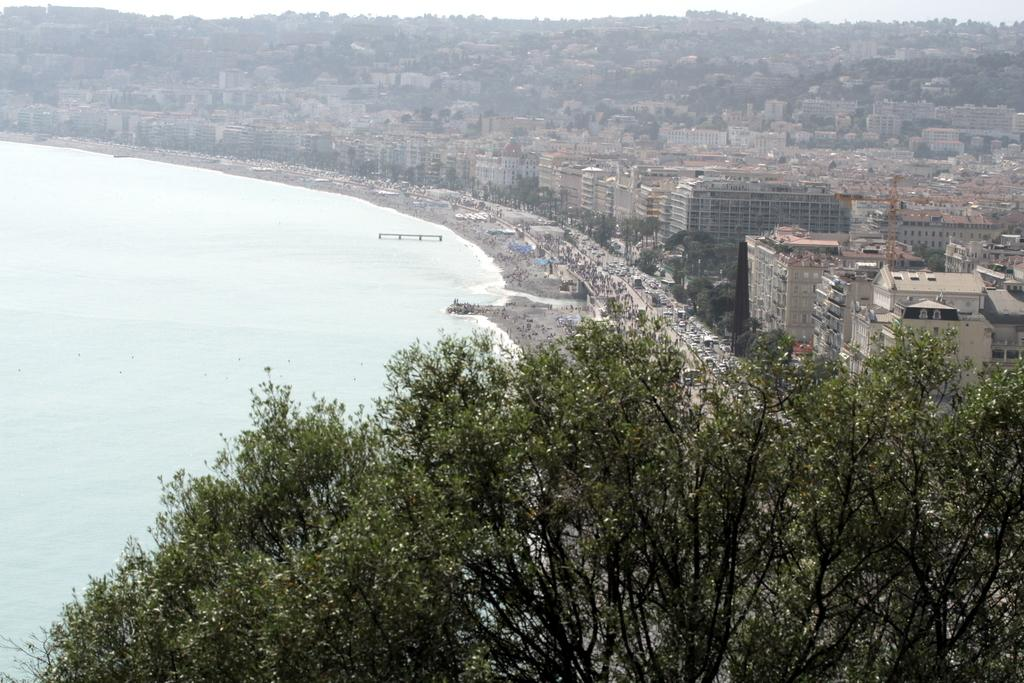What type of view is provided in the image? The image is an aerial view. What type of vegetation can be seen in the image? There are trees visible in the image. What natural element can be seen in the image? There is water visible in the image. What type of man-made structures can be seen in the image? There are buildings visible in the image. What is visible at the top of the image? The sky is visible at the top of the image. Where are the grapes located in the image? There are no grapes present in the image. What type of toys can be seen in the image? There are no toys present in the image. 